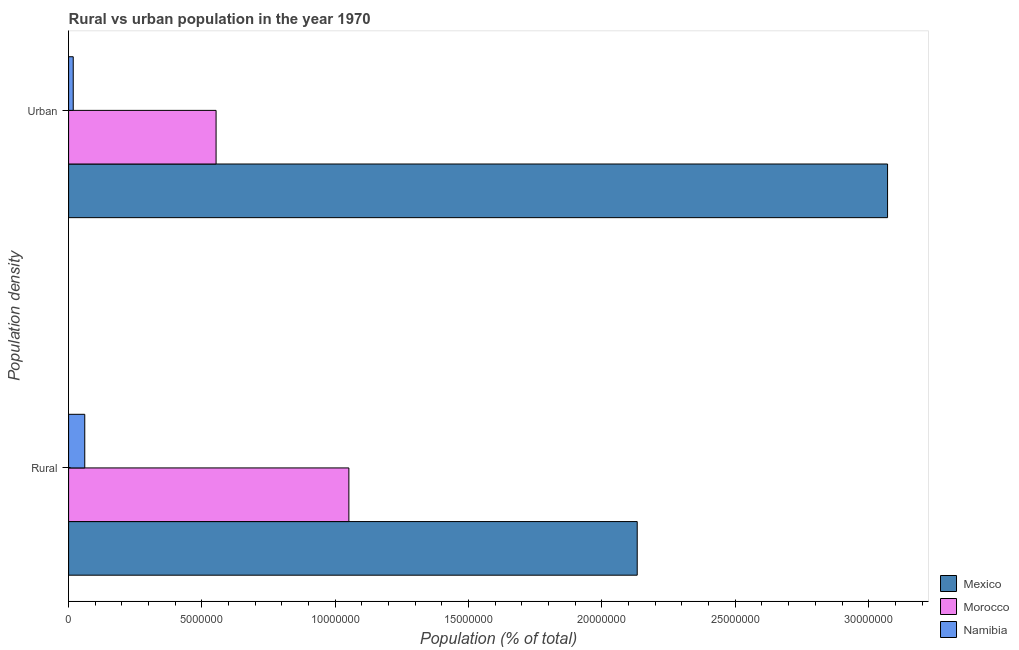How many different coloured bars are there?
Your response must be concise. 3. How many groups of bars are there?
Provide a short and direct response. 2. Are the number of bars per tick equal to the number of legend labels?
Your response must be concise. Yes. Are the number of bars on each tick of the Y-axis equal?
Provide a succinct answer. Yes. How many bars are there on the 2nd tick from the top?
Your answer should be compact. 3. What is the label of the 2nd group of bars from the top?
Provide a succinct answer. Rural. What is the urban population density in Namibia?
Your answer should be very brief. 1.74e+05. Across all countries, what is the maximum urban population density?
Ensure brevity in your answer.  3.07e+07. Across all countries, what is the minimum urban population density?
Offer a terse response. 1.74e+05. In which country was the urban population density minimum?
Your answer should be compact. Namibia. What is the total rural population density in the graph?
Offer a terse response. 3.24e+07. What is the difference between the rural population density in Morocco and that in Mexico?
Your answer should be very brief. -1.08e+07. What is the difference between the urban population density in Mexico and the rural population density in Morocco?
Give a very brief answer. 2.02e+07. What is the average rural population density per country?
Provide a short and direct response. 1.08e+07. What is the difference between the urban population density and rural population density in Morocco?
Give a very brief answer. -4.98e+06. In how many countries, is the urban population density greater than 22000000 %?
Your response must be concise. 1. What is the ratio of the urban population density in Namibia to that in Morocco?
Provide a succinct answer. 0.03. Is the urban population density in Mexico less than that in Namibia?
Provide a short and direct response. No. In how many countries, is the rural population density greater than the average rural population density taken over all countries?
Give a very brief answer. 1. What does the 2nd bar from the top in Rural represents?
Keep it short and to the point. Morocco. What does the 2nd bar from the bottom in Urban represents?
Your response must be concise. Morocco. What is the difference between two consecutive major ticks on the X-axis?
Your answer should be compact. 5.00e+06. How are the legend labels stacked?
Your answer should be very brief. Vertical. What is the title of the graph?
Your response must be concise. Rural vs urban population in the year 1970. What is the label or title of the X-axis?
Offer a terse response. Population (% of total). What is the label or title of the Y-axis?
Keep it short and to the point. Population density. What is the Population (% of total) in Mexico in Rural?
Provide a succinct answer. 2.13e+07. What is the Population (% of total) in Morocco in Rural?
Offer a terse response. 1.05e+07. What is the Population (% of total) of Namibia in Rural?
Offer a very short reply. 6.06e+05. What is the Population (% of total) in Mexico in Urban?
Your response must be concise. 3.07e+07. What is the Population (% of total) of Morocco in Urban?
Provide a short and direct response. 5.53e+06. What is the Population (% of total) of Namibia in Urban?
Offer a terse response. 1.74e+05. Across all Population density, what is the maximum Population (% of total) in Mexico?
Keep it short and to the point. 3.07e+07. Across all Population density, what is the maximum Population (% of total) of Morocco?
Make the answer very short. 1.05e+07. Across all Population density, what is the maximum Population (% of total) in Namibia?
Your answer should be compact. 6.06e+05. Across all Population density, what is the minimum Population (% of total) of Mexico?
Provide a succinct answer. 2.13e+07. Across all Population density, what is the minimum Population (% of total) of Morocco?
Provide a succinct answer. 5.53e+06. Across all Population density, what is the minimum Population (% of total) of Namibia?
Your answer should be very brief. 1.74e+05. What is the total Population (% of total) in Mexico in the graph?
Provide a short and direct response. 5.20e+07. What is the total Population (% of total) of Morocco in the graph?
Your answer should be very brief. 1.60e+07. What is the total Population (% of total) in Namibia in the graph?
Give a very brief answer. 7.80e+05. What is the difference between the Population (% of total) in Mexico in Rural and that in Urban?
Provide a succinct answer. -9.39e+06. What is the difference between the Population (% of total) in Morocco in Rural and that in Urban?
Make the answer very short. 4.98e+06. What is the difference between the Population (% of total) of Namibia in Rural and that in Urban?
Make the answer very short. 4.32e+05. What is the difference between the Population (% of total) of Mexico in Rural and the Population (% of total) of Morocco in Urban?
Your answer should be very brief. 1.58e+07. What is the difference between the Population (% of total) in Mexico in Rural and the Population (% of total) in Namibia in Urban?
Give a very brief answer. 2.11e+07. What is the difference between the Population (% of total) in Morocco in Rural and the Population (% of total) in Namibia in Urban?
Your response must be concise. 1.03e+07. What is the average Population (% of total) in Mexico per Population density?
Keep it short and to the point. 2.60e+07. What is the average Population (% of total) of Morocco per Population density?
Provide a succinct answer. 8.02e+06. What is the average Population (% of total) in Namibia per Population density?
Offer a terse response. 3.90e+05. What is the difference between the Population (% of total) of Mexico and Population (% of total) of Morocco in Rural?
Offer a very short reply. 1.08e+07. What is the difference between the Population (% of total) of Mexico and Population (% of total) of Namibia in Rural?
Offer a terse response. 2.07e+07. What is the difference between the Population (% of total) of Morocco and Population (% of total) of Namibia in Rural?
Offer a very short reply. 9.90e+06. What is the difference between the Population (% of total) of Mexico and Population (% of total) of Morocco in Urban?
Your response must be concise. 2.52e+07. What is the difference between the Population (% of total) in Mexico and Population (% of total) in Namibia in Urban?
Provide a succinct answer. 3.05e+07. What is the difference between the Population (% of total) in Morocco and Population (% of total) in Namibia in Urban?
Offer a terse response. 5.36e+06. What is the ratio of the Population (% of total) in Mexico in Rural to that in Urban?
Provide a short and direct response. 0.69. What is the ratio of the Population (% of total) in Morocco in Rural to that in Urban?
Ensure brevity in your answer.  1.9. What is the ratio of the Population (% of total) of Namibia in Rural to that in Urban?
Give a very brief answer. 3.49. What is the difference between the highest and the second highest Population (% of total) in Mexico?
Ensure brevity in your answer.  9.39e+06. What is the difference between the highest and the second highest Population (% of total) of Morocco?
Ensure brevity in your answer.  4.98e+06. What is the difference between the highest and the second highest Population (% of total) of Namibia?
Keep it short and to the point. 4.32e+05. What is the difference between the highest and the lowest Population (% of total) of Mexico?
Your answer should be compact. 9.39e+06. What is the difference between the highest and the lowest Population (% of total) in Morocco?
Make the answer very short. 4.98e+06. What is the difference between the highest and the lowest Population (% of total) of Namibia?
Your answer should be very brief. 4.32e+05. 